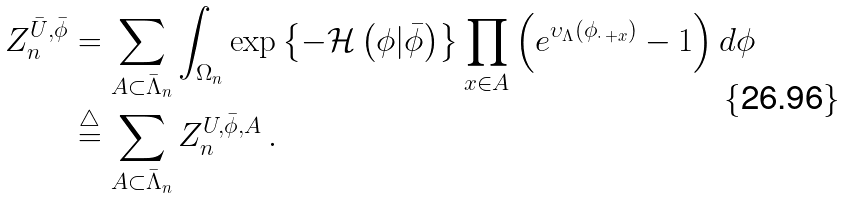<formula> <loc_0><loc_0><loc_500><loc_500>Z _ { n } ^ { \bar { U } , \bar { \phi } } & = \sum _ { A \subset \bar { \Lambda } _ { n } } \int _ { \Omega _ { n } } \exp \left \{ - \mathcal { H } \left ( \phi | \bar { \phi } \right ) \right \} \prod _ { x \in A } \left ( e ^ { \upsilon _ { \Lambda } \left ( \phi _ { \cdot \, + x } \right ) } - 1 \right ) d \phi \\ & \overset { \triangle } { = } \sum _ { A \subset \bar { \Lambda } _ { n } } Z _ { n } ^ { U , \bar { \phi } , A } \, .</formula> 